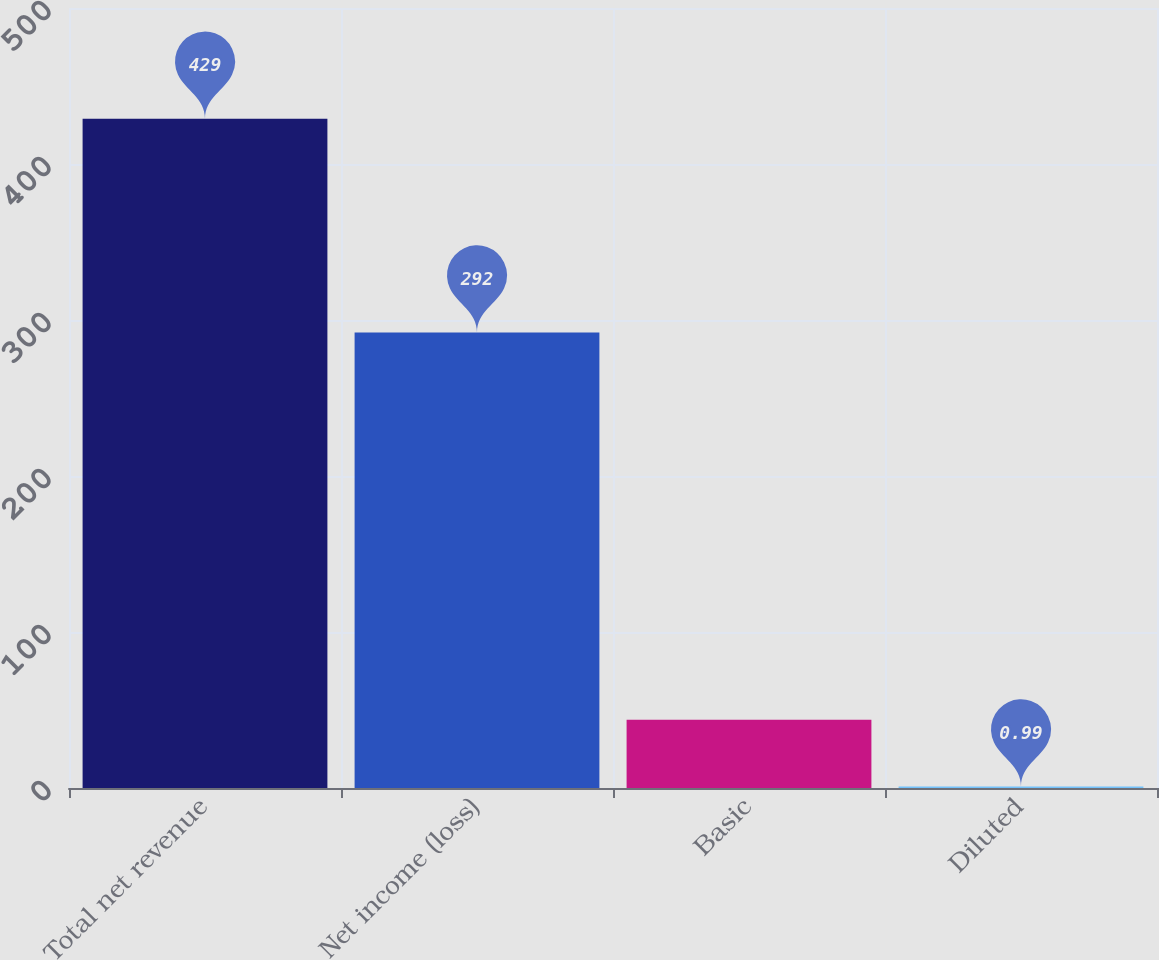<chart> <loc_0><loc_0><loc_500><loc_500><bar_chart><fcel>Total net revenue<fcel>Net income (loss)<fcel>Basic<fcel>Diluted<nl><fcel>429<fcel>292<fcel>43.79<fcel>0.99<nl></chart> 